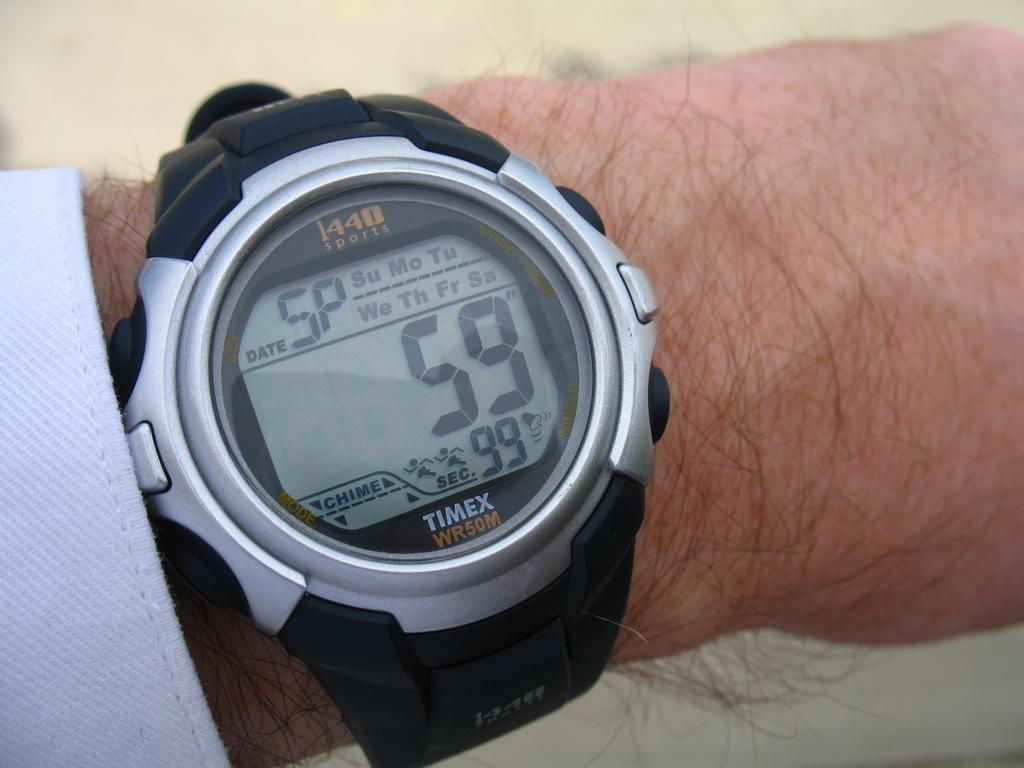Provide a one-sentence caption for the provided image. The black and silver TIMEX watch has a digital face with a chime button. 